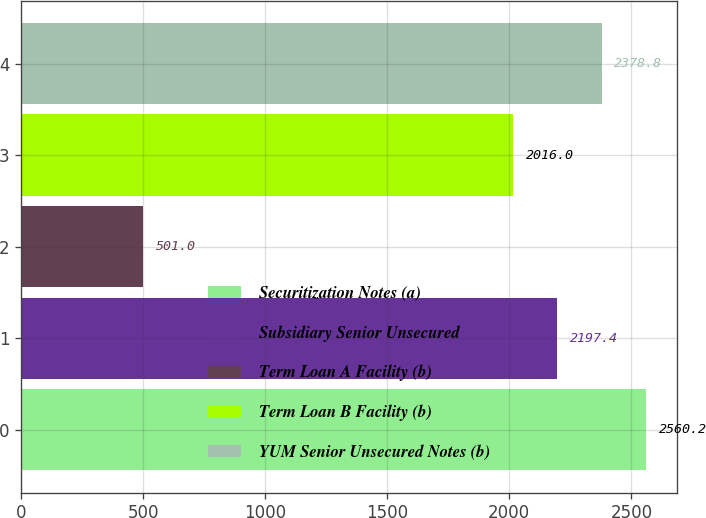Convert chart. <chart><loc_0><loc_0><loc_500><loc_500><bar_chart><fcel>Securitization Notes (a)<fcel>Subsidiary Senior Unsecured<fcel>Term Loan A Facility (b)<fcel>Term Loan B Facility (b)<fcel>YUM Senior Unsecured Notes (b)<nl><fcel>2560.2<fcel>2197.4<fcel>501<fcel>2016<fcel>2378.8<nl></chart> 